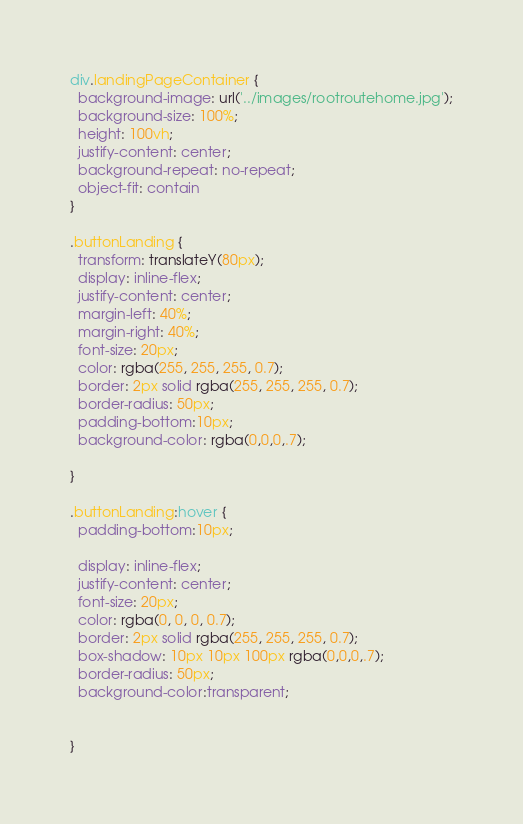<code> <loc_0><loc_0><loc_500><loc_500><_CSS_>div.landingPageContainer {
  background-image: url('../images/rootroutehome.jpg');
  background-size: 100%;
  height: 100vh;
  justify-content: center;
  background-repeat: no-repeat;
  object-fit: contain
}

.buttonLanding {
  transform: translateY(80px);
  display: inline-flex;
  justify-content: center;
  margin-left: 40%;
  margin-right: 40%;
  font-size: 20px;
  color: rgba(255, 255, 255, 0.7);
  border: 2px solid rgba(255, 255, 255, 0.7);
  border-radius: 50px;
  padding-bottom:10px;
  background-color: rgba(0,0,0,.7);
  
}

.buttonLanding:hover {
  padding-bottom:10px;

  display: inline-flex;
  justify-content: center;
  font-size: 20px;
  color: rgba(0, 0, 0, 0.7);
  border: 2px solid rgba(255, 255, 255, 0.7);
  box-shadow: 10px 10px 100px rgba(0,0,0,.7);
  border-radius: 50px;
  background-color:transparent;


}
</code> 